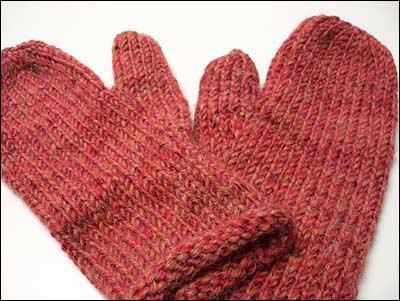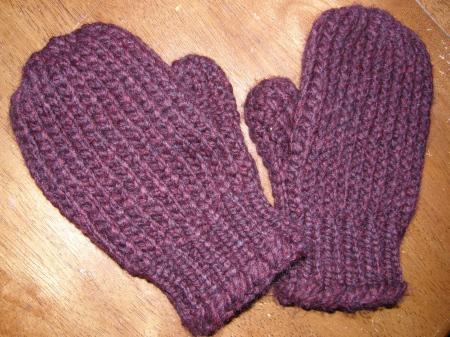The first image is the image on the left, the second image is the image on the right. Analyze the images presented: Is the assertion "The mittens in the image on the right have hands in them." valid? Answer yes or no. No. 